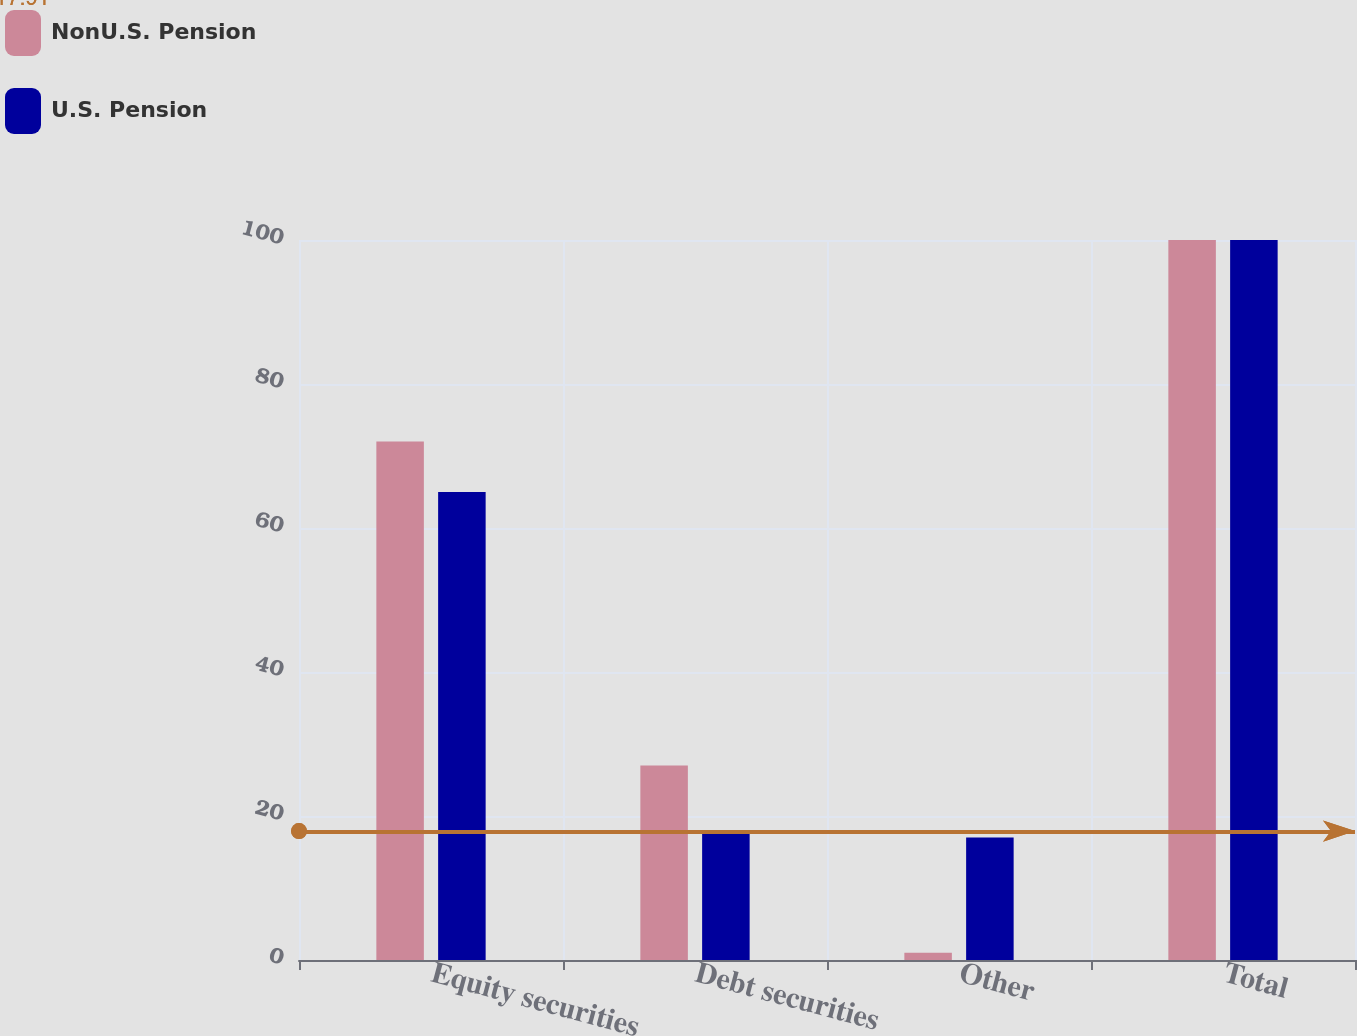Convert chart. <chart><loc_0><loc_0><loc_500><loc_500><stacked_bar_chart><ecel><fcel>Equity securities<fcel>Debt securities<fcel>Other<fcel>Total<nl><fcel>NonU.S. Pension<fcel>72<fcel>27<fcel>1<fcel>100<nl><fcel>U.S. Pension<fcel>65<fcel>18<fcel>17<fcel>100<nl></chart> 